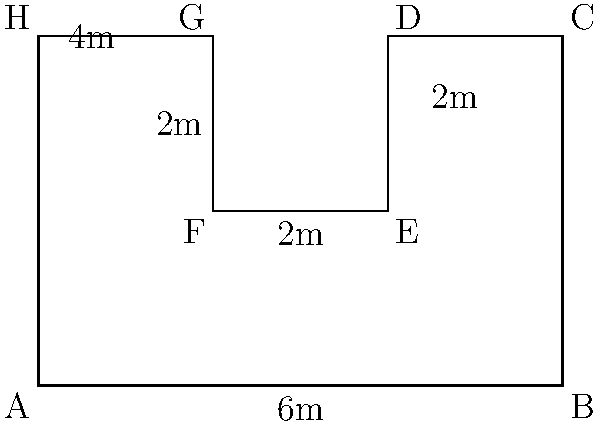A community garden plot has an irregular shape as shown in the diagram. Calculate the total area of this garden plot in square meters. How might this information be useful when planning volunteer activities for the community garden? To calculate the area of this irregular shape, we can break it down into rectangles:

1. First, identify the rectangles:
   - Rectangle 1: ABCH (6m x 4m)
   - Rectangle 2: DEFG (2m x 2m)

2. Calculate the area of Rectangle 1:
   $$A_1 = 6m \times 4m = 24m^2$$

3. Calculate the area of Rectangle 2:
   $$A_2 = 2m \times 2m = 4m^2$$

4. Subtract the area of Rectangle 2 from Rectangle 1:
   $$A_{total} = A_1 - A_2 = 24m^2 - 4m^2 = 20m^2$$

The total area of the garden plot is 20 square meters.

This information is useful for planning volunteer activities because:
1. It helps determine how many plants can be accommodated in the space.
2. It aids in estimating the amount of soil, mulch, or other materials needed.
3. It helps in organizing volunteer groups and assigning tasks based on the garden's size.
4. It assists in planning irrigation systems or determining water requirements.
5. It can be used to calculate potential yield for vegetable or fruit crops.
Answer: 20 square meters 